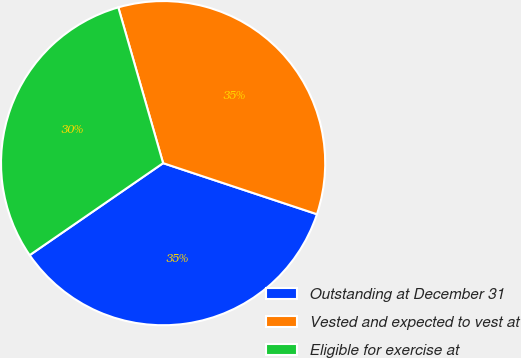Convert chart. <chart><loc_0><loc_0><loc_500><loc_500><pie_chart><fcel>Outstanding at December 31<fcel>Vested and expected to vest at<fcel>Eligible for exercise at<nl><fcel>35.29%<fcel>34.56%<fcel>30.15%<nl></chart> 